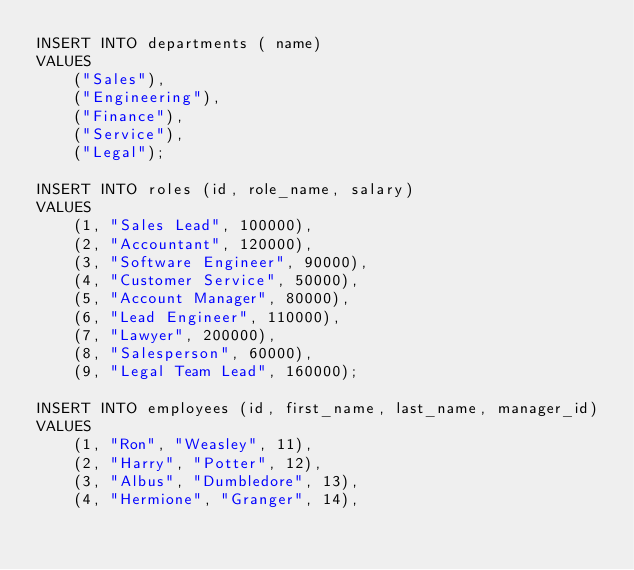Convert code to text. <code><loc_0><loc_0><loc_500><loc_500><_SQL_>INSERT INTO departments ( name)
VALUES 
    ("Sales"),
    ("Engineering"),
    ("Finance"),
    ("Service"),
    ("Legal");

INSERT INTO roles (id, role_name, salary)
VALUES 
    (1, "Sales Lead", 100000),
    (2, "Accountant", 120000),
    (3, "Software Engineer", 90000),
    (4, "Customer Service", 50000),
    (5, "Account Manager", 80000),
    (6, "Lead Engineer", 110000),
    (7, "Lawyer", 200000),
    (8, "Salesperson", 60000),
    (9, "Legal Team Lead", 160000);

INSERT INTO employees (id, first_name, last_name, manager_id)
VALUES 
    (1, "Ron", "Weasley", 11),
    (2, "Harry", "Potter", 12),
    (3, "Albus", "Dumbledore", 13),
    (4, "Hermione", "Granger", 14),</code> 